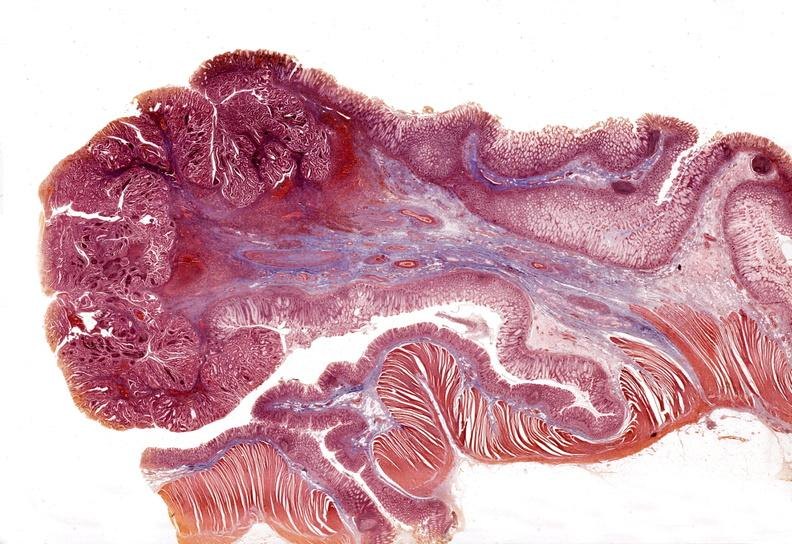s source present?
Answer the question using a single word or phrase. No 